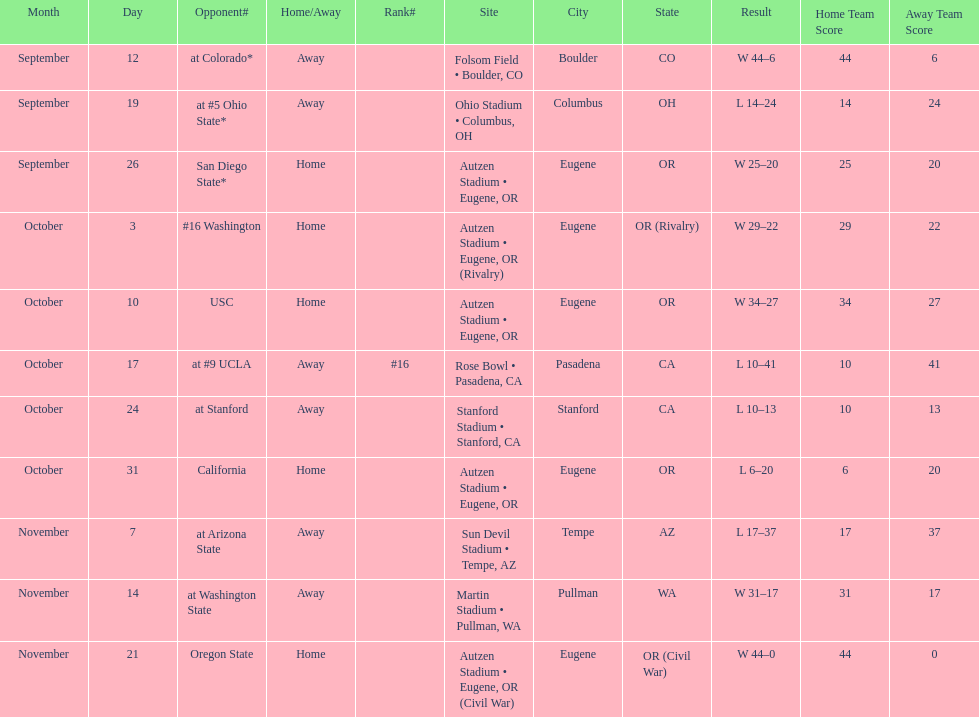Between september 26 and october 24, how many games were played in eugene, or? 3. 